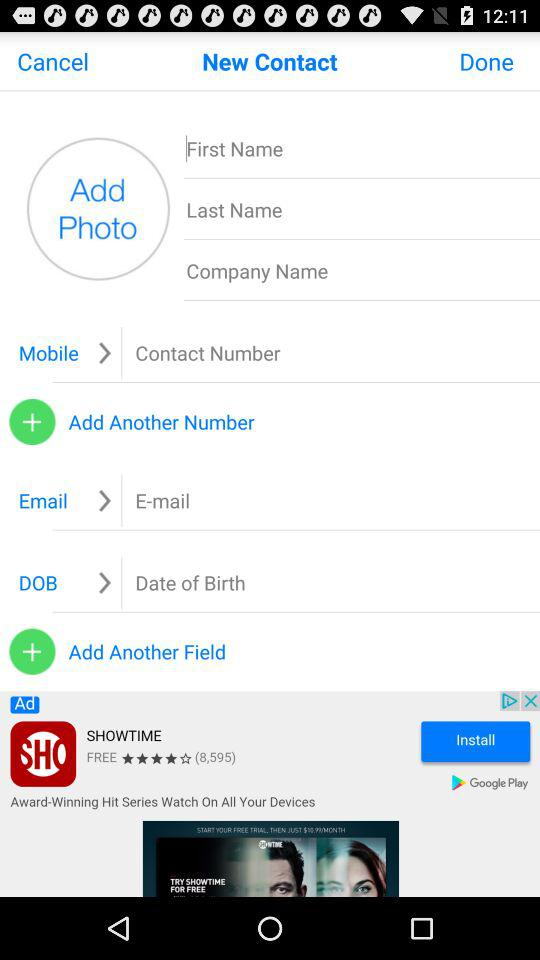What is the number? The number is 4155790909. 